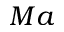Convert formula to latex. <formula><loc_0><loc_0><loc_500><loc_500>M a</formula> 